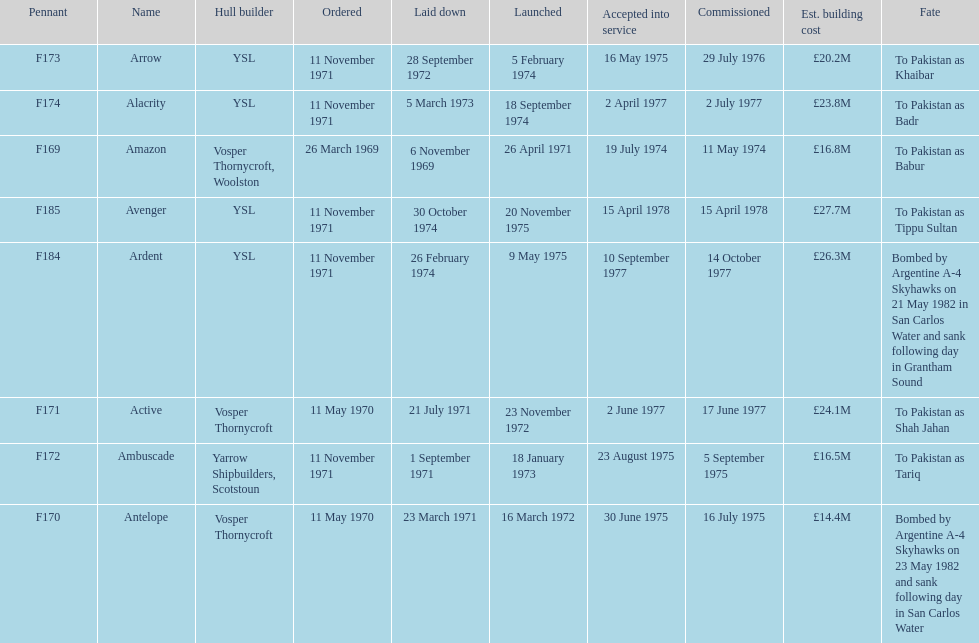How many ships were laid down in september? 2. 